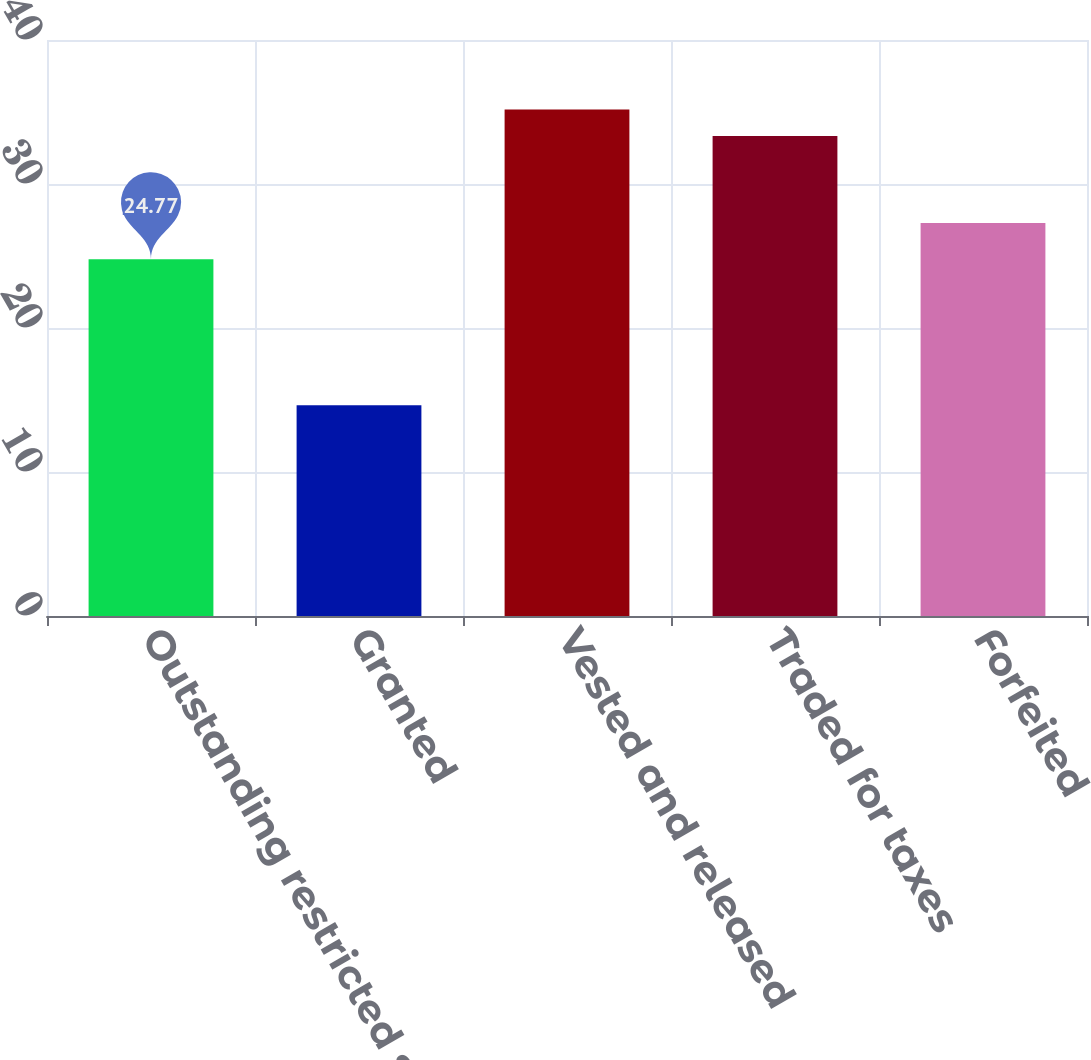Convert chart. <chart><loc_0><loc_0><loc_500><loc_500><bar_chart><fcel>Outstanding restricted stock<fcel>Granted<fcel>Vested and released<fcel>Traded for taxes<fcel>Forfeited<nl><fcel>24.77<fcel>14.63<fcel>35.18<fcel>33.34<fcel>27.3<nl></chart> 